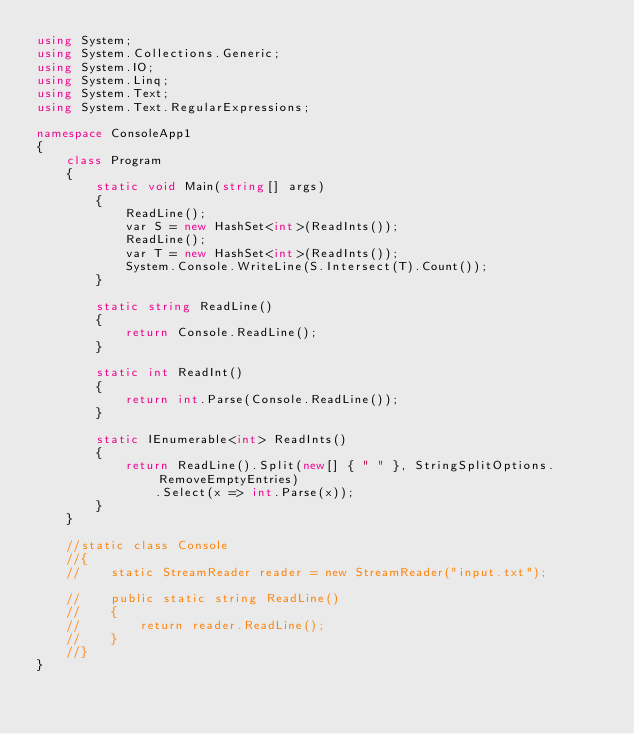<code> <loc_0><loc_0><loc_500><loc_500><_C#_>using System;
using System.Collections.Generic;
using System.IO;
using System.Linq;
using System.Text;
using System.Text.RegularExpressions;

namespace ConsoleApp1
{
    class Program
    {
        static void Main(string[] args)
        {
            ReadLine();
            var S = new HashSet<int>(ReadInts());
            ReadLine();
            var T = new HashSet<int>(ReadInts());
            System.Console.WriteLine(S.Intersect(T).Count());
        }

        static string ReadLine()
        {
            return Console.ReadLine();
        }

        static int ReadInt()
        {
            return int.Parse(Console.ReadLine());
        }

        static IEnumerable<int> ReadInts()
        {
            return ReadLine().Split(new[] { " " }, StringSplitOptions.RemoveEmptyEntries)
                .Select(x => int.Parse(x));
        }
    }

    //static class Console
    //{
    //    static StreamReader reader = new StreamReader("input.txt");

    //    public static string ReadLine()
    //    {
    //        return reader.ReadLine();
    //    }
    //}
}</code> 